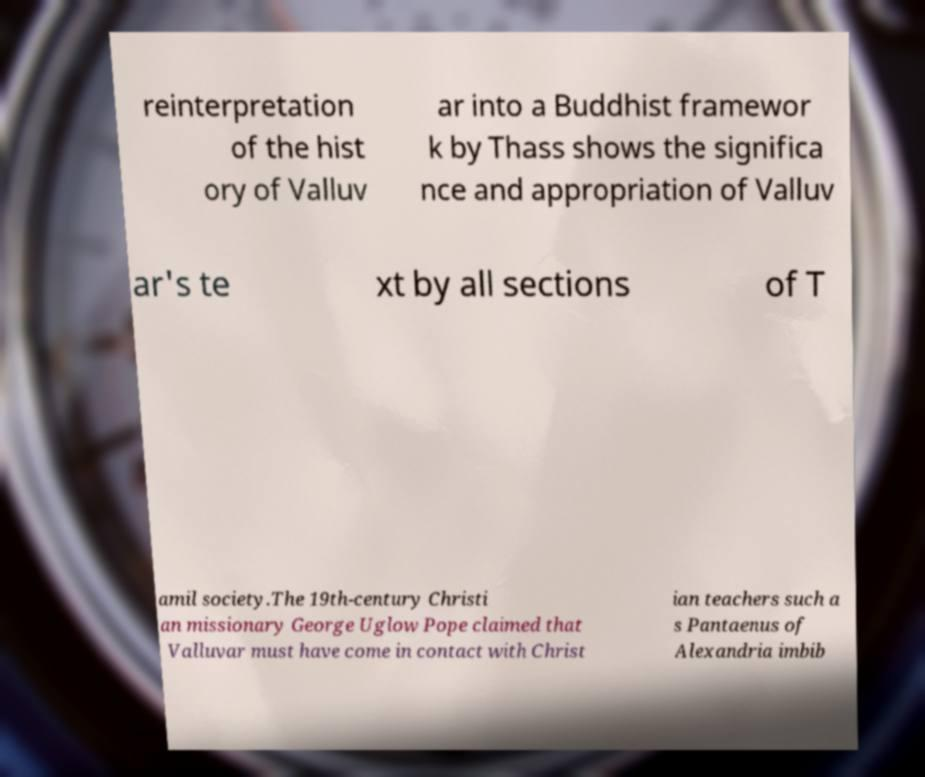Please read and relay the text visible in this image. What does it say? reinterpretation of the hist ory of Valluv ar into a Buddhist framewor k by Thass shows the significa nce and appropriation of Valluv ar's te xt by all sections of T amil society.The 19th-century Christi an missionary George Uglow Pope claimed that Valluvar must have come in contact with Christ ian teachers such a s Pantaenus of Alexandria imbib 